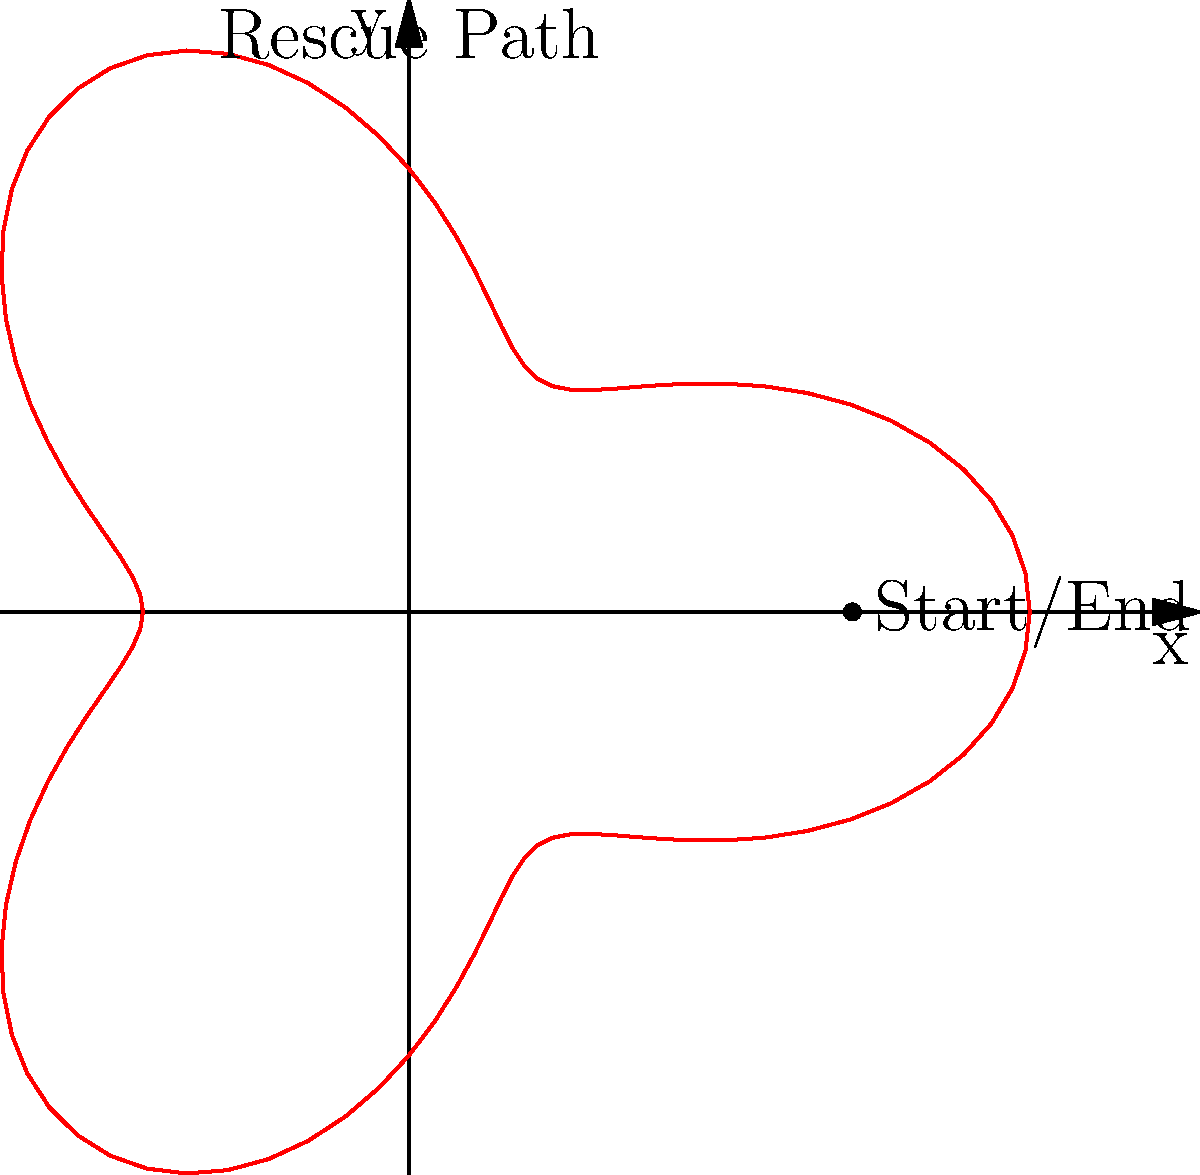A rescue helicopter follows a path described by the polar equation $r = 5 + 2\cos(3\theta)$ (in kilometers). If the helicopter makes one complete loop, what is the total angular displacement it travels? To find the total angular displacement, we need to consider the following steps:

1. Recall that $\theta$ represents the angular displacement in polar coordinates.

2. The equation $r = 5 + 2\cos(3\theta)$ describes a rose curve with three petals.

3. For a complete loop, we need to determine when the curve returns to its starting point.

4. The period of $\cos(3\theta)$ is $\frac{2\pi}{3}$.

5. However, to complete one full loop of the entire curve, we need to go through all three petals.

6. Therefore, the total angular displacement is:

   $$\text{Total angular displacement} = 3 \times \frac{2\pi}{3} = 2\pi \text{ radians}$$

7. This is equivalent to one full rotation (360°).
Answer: $2\pi$ radians 